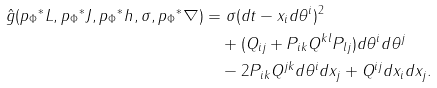<formula> <loc_0><loc_0><loc_500><loc_500>\hat { g } ( { p _ { \Phi } } ^ { * } L , { p _ { \Phi } } ^ { * } J , { p _ { \Phi } } ^ { * } h , \sigma , { p _ { \Phi } } ^ { * } \nabla ) & = \sigma ( d t - x _ { i } d \theta ^ { i } ) ^ { 2 } \\ & \quad + ( Q _ { i j } + P _ { i k } Q ^ { k l } P _ { l j } ) d \theta ^ { i } d \theta ^ { j } \\ & \quad - 2 P _ { i k } Q ^ { j k } d \theta ^ { i } d x _ { j } + Q ^ { i j } d x _ { i } d x _ { j } .</formula> 